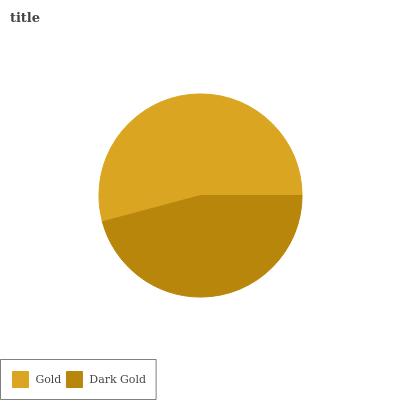Is Dark Gold the minimum?
Answer yes or no. Yes. Is Gold the maximum?
Answer yes or no. Yes. Is Dark Gold the maximum?
Answer yes or no. No. Is Gold greater than Dark Gold?
Answer yes or no. Yes. Is Dark Gold less than Gold?
Answer yes or no. Yes. Is Dark Gold greater than Gold?
Answer yes or no. No. Is Gold less than Dark Gold?
Answer yes or no. No. Is Gold the high median?
Answer yes or no. Yes. Is Dark Gold the low median?
Answer yes or no. Yes. Is Dark Gold the high median?
Answer yes or no. No. Is Gold the low median?
Answer yes or no. No. 